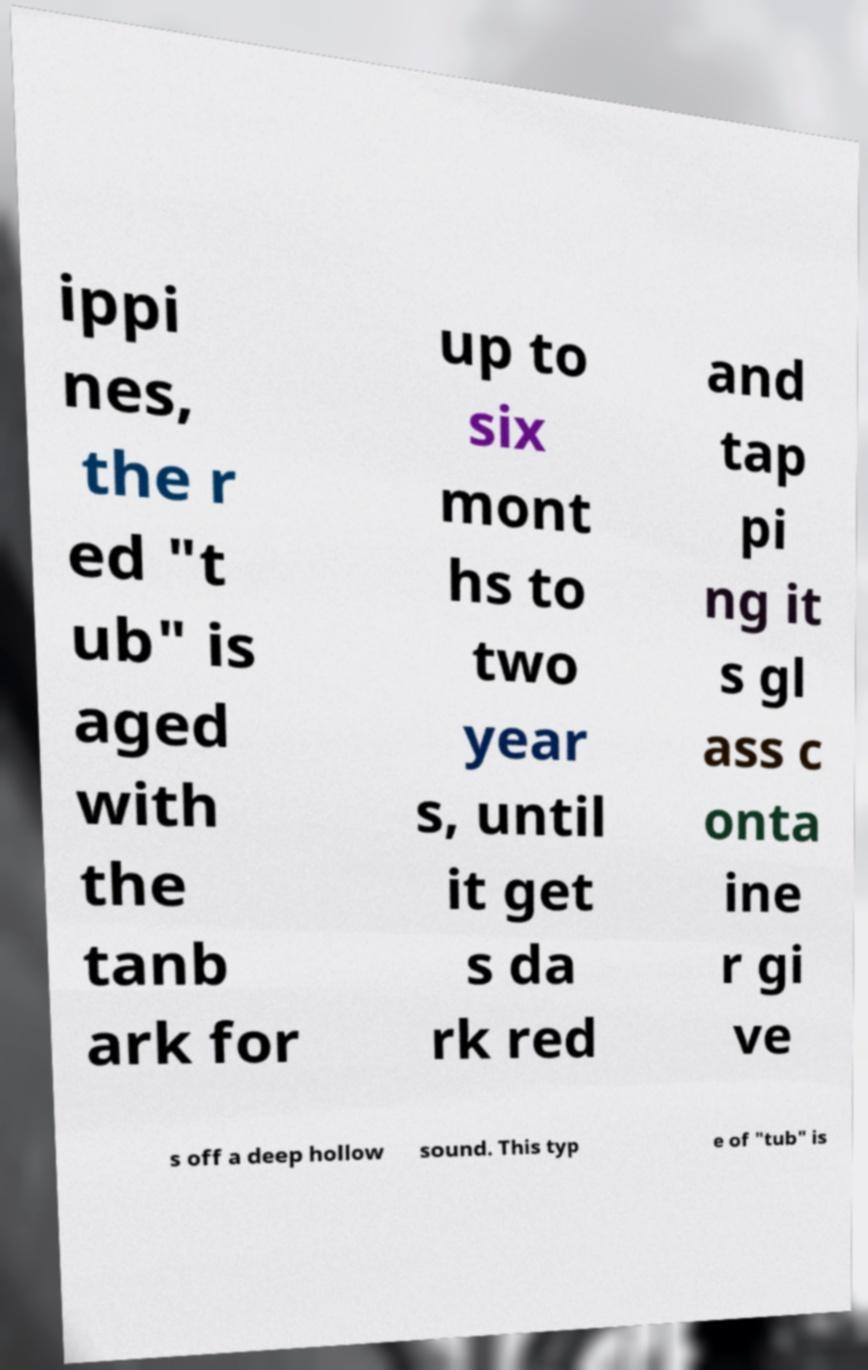Please identify and transcribe the text found in this image. ippi nes, the r ed "t ub" is aged with the tanb ark for up to six mont hs to two year s, until it get s da rk red and tap pi ng it s gl ass c onta ine r gi ve s off a deep hollow sound. This typ e of "tub" is 